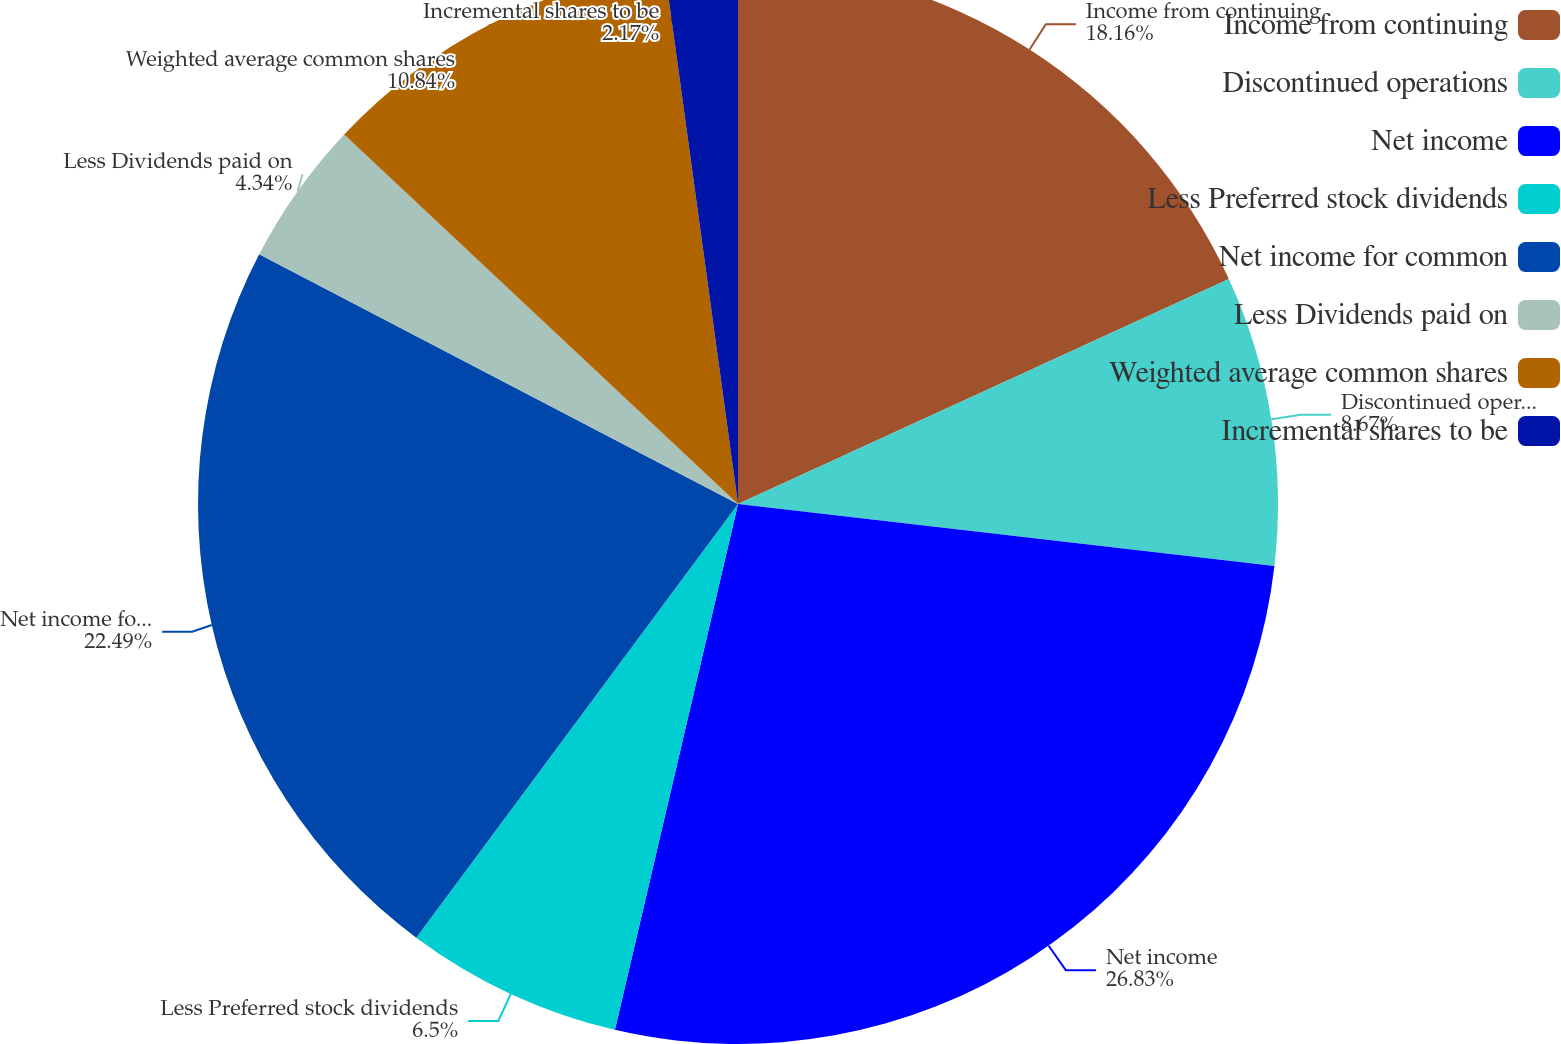Convert chart to OTSL. <chart><loc_0><loc_0><loc_500><loc_500><pie_chart><fcel>Income from continuing<fcel>Discontinued operations<fcel>Net income<fcel>Less Preferred stock dividends<fcel>Net income for common<fcel>Less Dividends paid on<fcel>Weighted average common shares<fcel>Incremental shares to be<nl><fcel>18.16%<fcel>8.67%<fcel>26.83%<fcel>6.5%<fcel>22.49%<fcel>4.34%<fcel>10.84%<fcel>2.17%<nl></chart> 